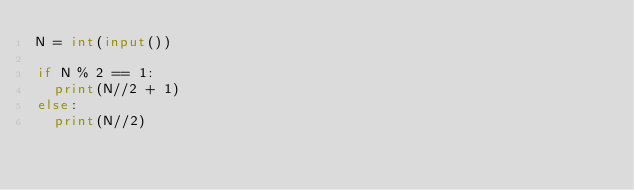Convert code to text. <code><loc_0><loc_0><loc_500><loc_500><_Python_>N = int(input())

if N % 2 == 1:
  print(N//2 + 1)
else:
  print(N//2)</code> 